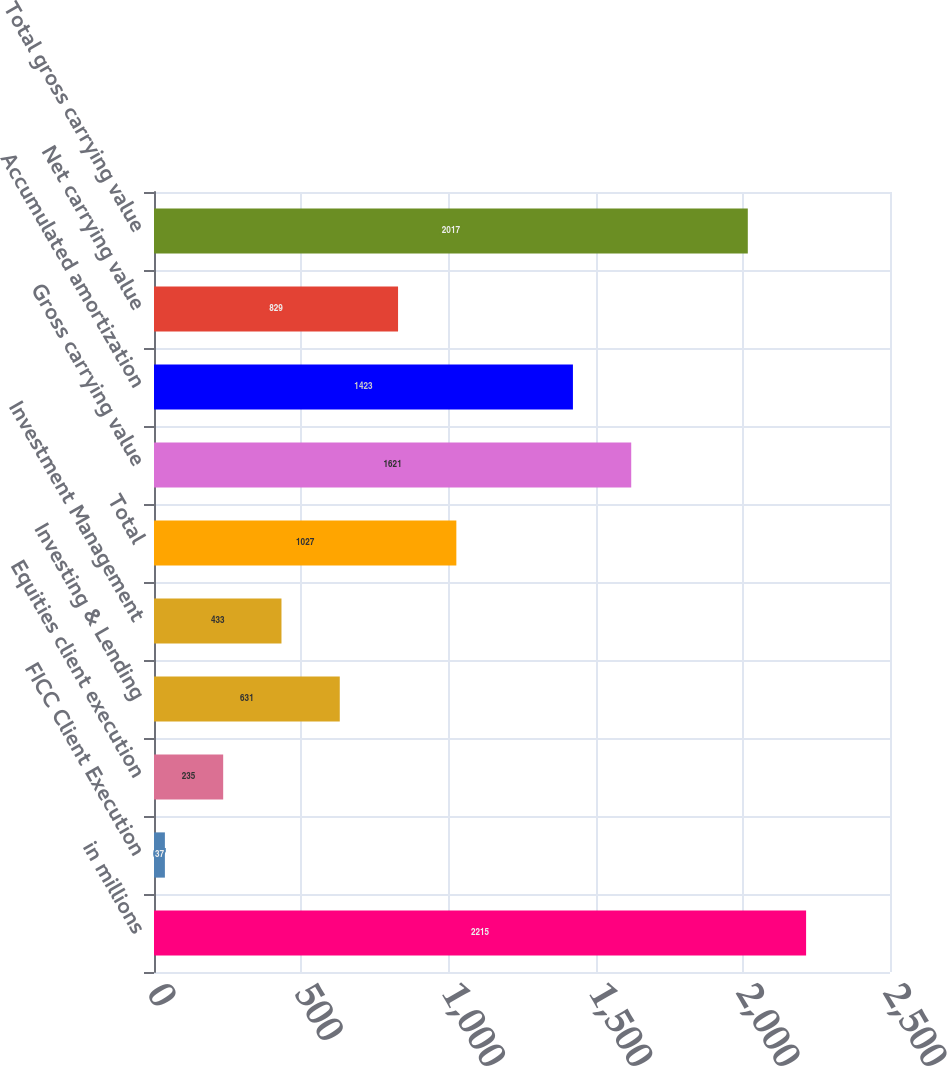Convert chart to OTSL. <chart><loc_0><loc_0><loc_500><loc_500><bar_chart><fcel>in millions<fcel>FICC Client Execution<fcel>Equities client execution<fcel>Investing & Lending<fcel>Investment Management<fcel>Total<fcel>Gross carrying value<fcel>Accumulated amortization<fcel>Net carrying value<fcel>Total gross carrying value<nl><fcel>2215<fcel>37<fcel>235<fcel>631<fcel>433<fcel>1027<fcel>1621<fcel>1423<fcel>829<fcel>2017<nl></chart> 